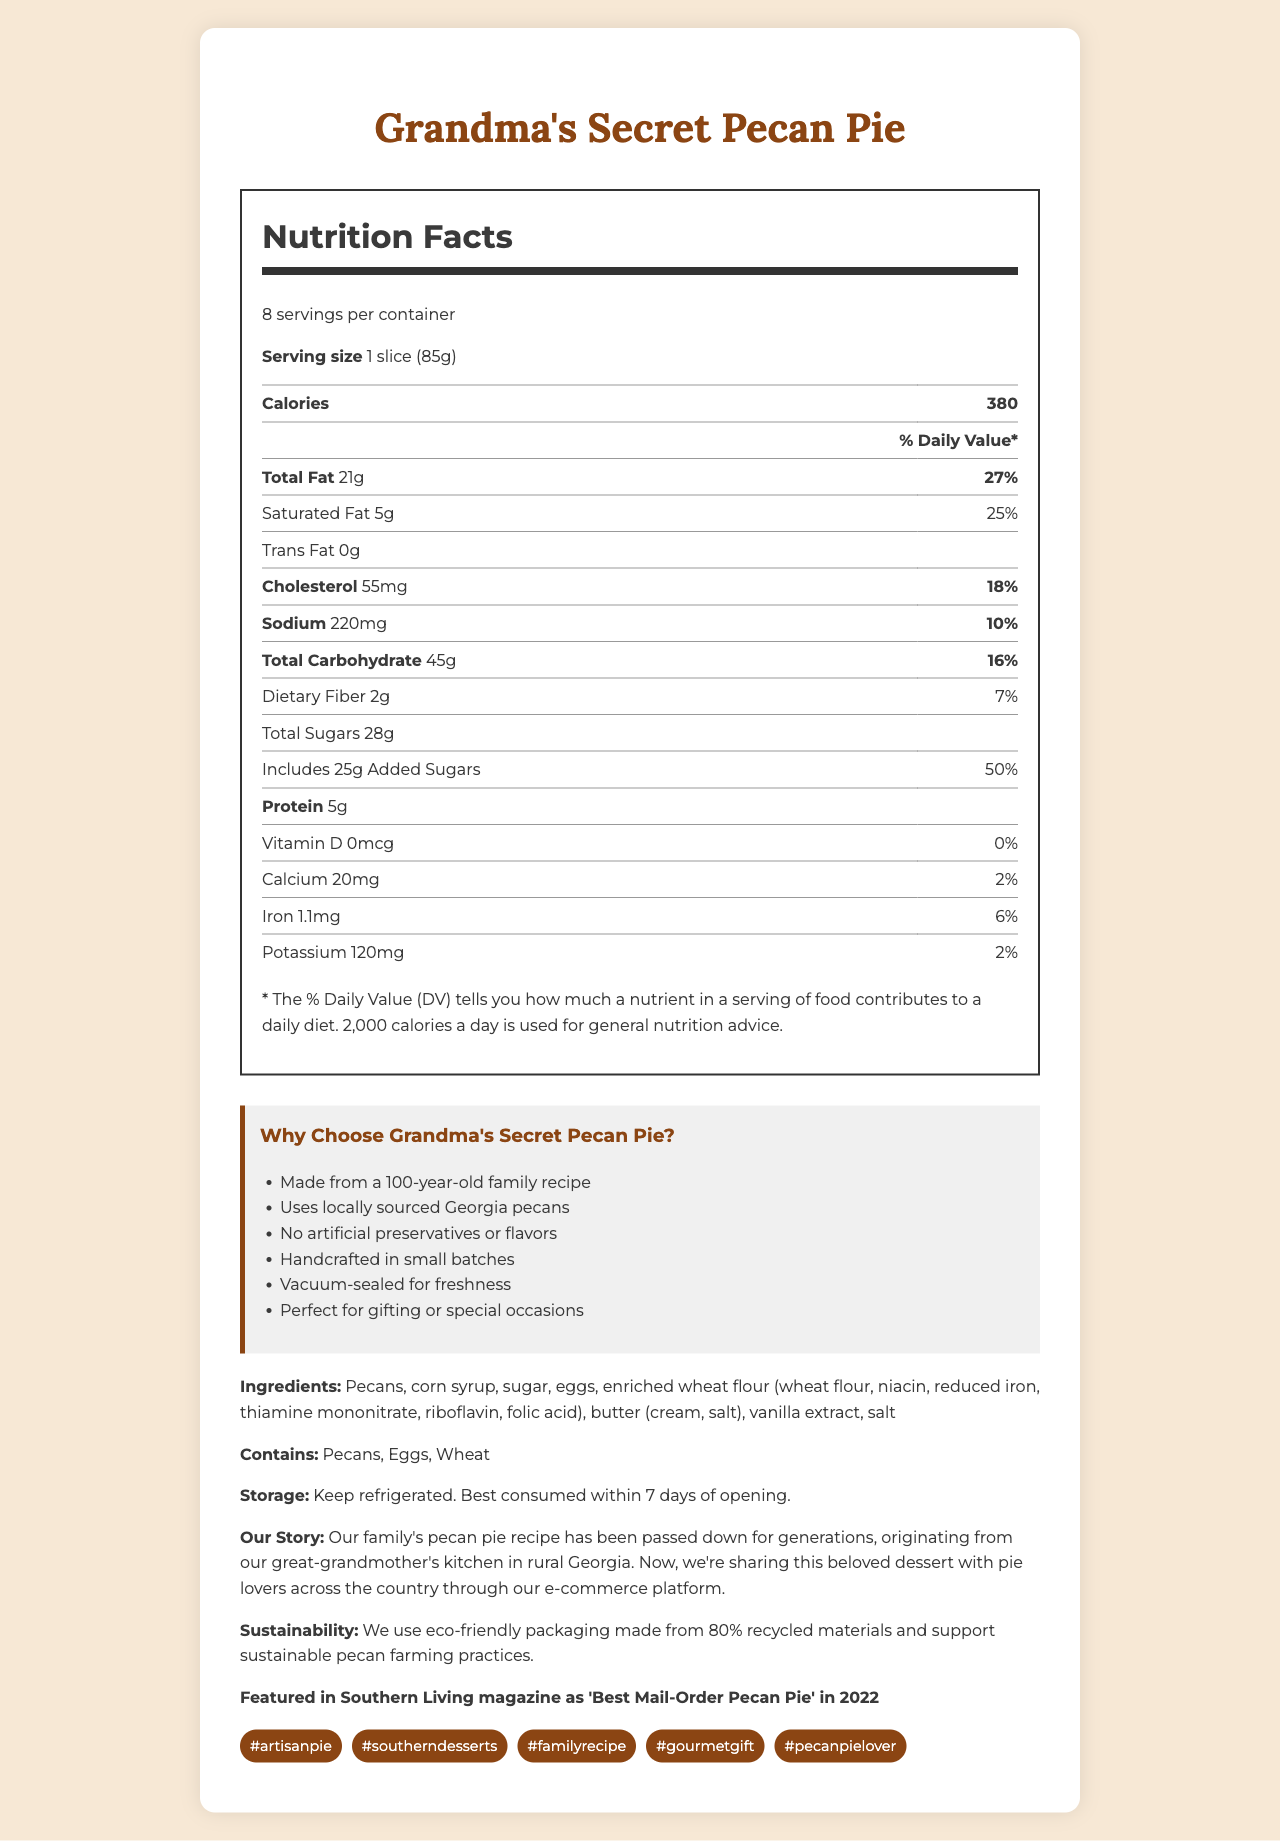who should consume grandma's secret pecan pie? The brand story mentions, "we're sharing this beloved dessert with pie lovers across the country through our e-commerce platform."
Answer: Pie lovers across the country, especially those who love a handcrafted, artisan dessert. what is the serving size of grandma's secret pecan pie? The Nutrition Facts section states the serving size is "1 slice (85g)."
Answer: 1 slice (85g) how much total fat is there per serving? The Nutrition Facts section lists "Total Fat" as "21g."
Answer: 21g why is grandma's secret pecan pie unique? A. Made with organic pecans B. Handcrafted in small batches C. Contains no pecans D. Uses secret artificial flavors The unique selling points state that the pie is "Handcrafted in small batches."
Answer: B what are the allergens in grandma's secret pecan pie? The document lists "Contains: Pecans, Eggs, Wheat."
Answer: Pecans, Eggs, Wheat what is the percentage of daily value for added sugars in one serving? The Nutrition Facts section indicates the "Added Sugars" daily value as "50%."
Answer: 50% which magazine featured grandma's secret pecan pie? A. Cooking Light B. Food Network Magazine C. Southern Living D. Better Homes & Gardens The document states it was "Featured in Southern Living magazine as 'Best Mail-Order Pecan Pie' in 2022."
Answer: C does grandma's secret pecan pie contain artificial preservatives? One of the unique selling points is "No artificial preservatives or flavors."
Answer: No summarize the document. The document provides a comprehensive overview of Grandma's Secret Pecan Pie, touching on its nutritional information, unique qualities, and background, making it appealing for e-commerce and potential customers.
Answer: The document features Grandma's Secret Pecan Pie, highlighting its nutrition facts, unique selling points, ingredients, allergens, storage instructions, brand story, sustainability practices, and social proof. It emphasizes the pie as a handcrafted, artisanal product made from a 100-year-old family recipe using locally sourced pecans and eco-friendly packaging. what is the calcium content per serving? The Nutrition Facts section lists the calcium content as "20mg."
Answer: 20mg what dietary lifestyle benefits does this pie offer? The document does not provide specific details about dietary lifestyle benefits such as being gluten-free, vegan, or keto-friendly.
Answer: Not enough information what hashtags could be used for digital marketing? The document lists the digital marketing tags at the end as potential hashtags for online promotion.
Answer: #artisanpie, #southerndesserts, #familyrecipe, #gourmetgift, #pecanpielover 